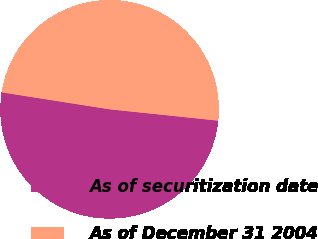Convert chart. <chart><loc_0><loc_0><loc_500><loc_500><pie_chart><fcel>As of securitization date<fcel>As of December 31 2004<nl><fcel>50.83%<fcel>49.17%<nl></chart> 